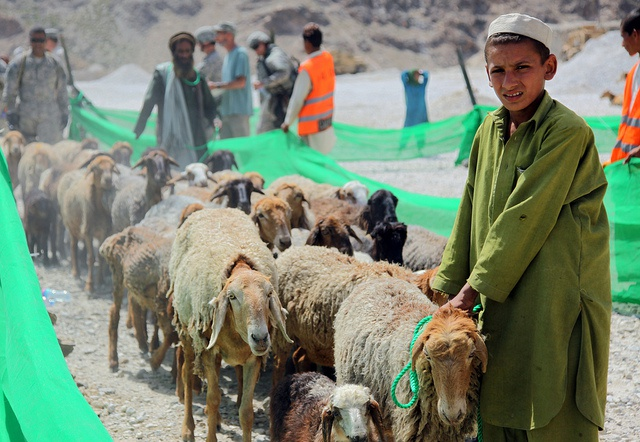Describe the objects in this image and their specific colors. I can see people in gray, darkgreen, black, and olive tones, sheep in gray, darkgray, black, and tan tones, sheep in gray, tan, olive, and darkgray tones, sheep in gray, black, and tan tones, and sheep in gray and darkgray tones in this image. 